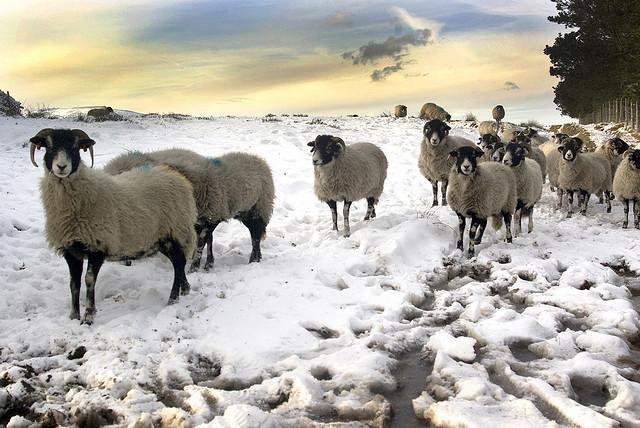How many sheep are there?
Give a very brief answer. 8. 